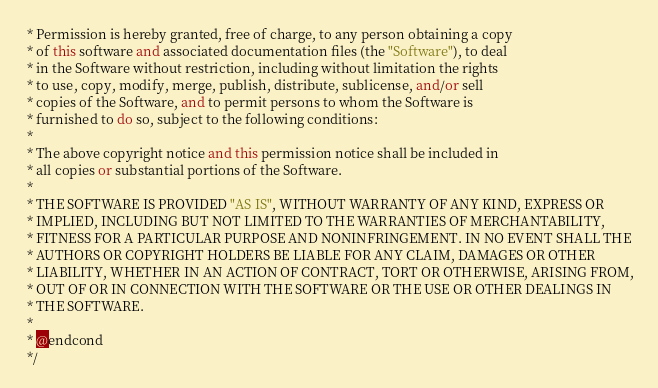Convert code to text. <code><loc_0><loc_0><loc_500><loc_500><_C++_> * Permission is hereby granted, free of charge, to any person obtaining a copy
 * of this software and associated documentation files (the "Software"), to deal
 * in the Software without restriction, including without limitation the rights
 * to use, copy, modify, merge, publish, distribute, sublicense, and/or sell
 * copies of the Software, and to permit persons to whom the Software is
 * furnished to do so, subject to the following conditions:
 *
 * The above copyright notice and this permission notice shall be included in
 * all copies or substantial portions of the Software.
 *
 * THE SOFTWARE IS PROVIDED "AS IS", WITHOUT WARRANTY OF ANY KIND, EXPRESS OR
 * IMPLIED, INCLUDING BUT NOT LIMITED TO THE WARRANTIES OF MERCHANTABILITY,
 * FITNESS FOR A PARTICULAR PURPOSE AND NONINFRINGEMENT. IN NO EVENT SHALL THE
 * AUTHORS OR COPYRIGHT HOLDERS BE LIABLE FOR ANY CLAIM, DAMAGES OR OTHER
 * LIABILITY, WHETHER IN AN ACTION OF CONTRACT, TORT OR OTHERWISE, ARISING FROM,
 * OUT OF OR IN CONNECTION WITH THE SOFTWARE OR THE USE OR OTHER DEALINGS IN
 * THE SOFTWARE.
 *
 * @endcond
 */
</code> 